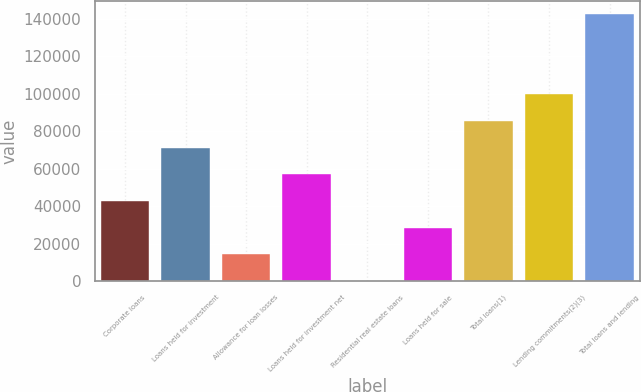<chart> <loc_0><loc_0><loc_500><loc_500><bar_chart><fcel>Corporate loans<fcel>Loans held for investment<fcel>Allowance for loan losses<fcel>Loans held for investment net<fcel>Residential real estate loans<fcel>Loans held for sale<fcel>Total loans(1)<fcel>Lending commitments(2)(3)<fcel>Total loans and lending<nl><fcel>42759.6<fcel>71236<fcel>14283.2<fcel>56997.8<fcel>45<fcel>28521.4<fcel>85474.2<fcel>99712.4<fcel>142427<nl></chart> 